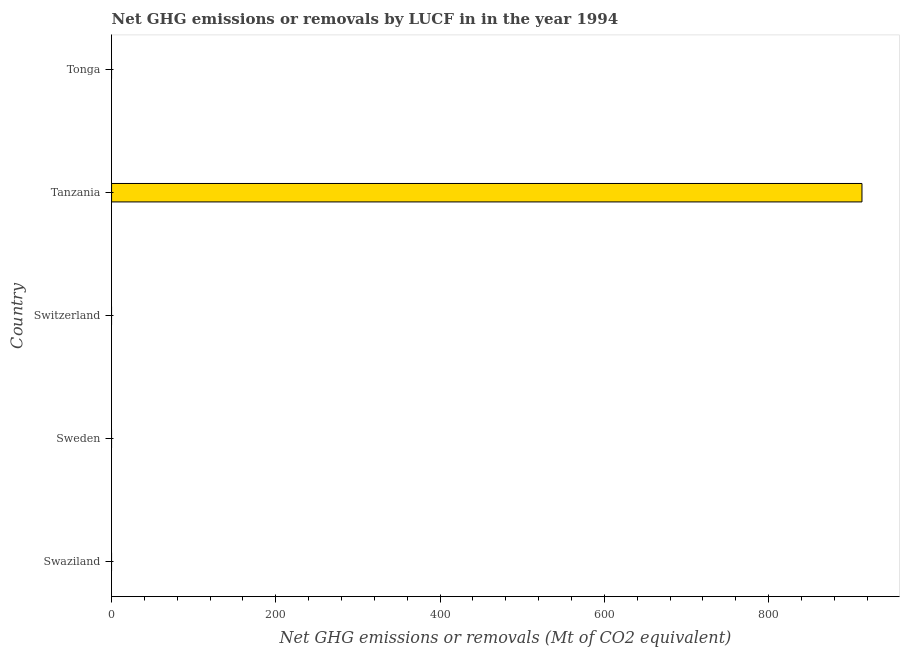Does the graph contain any zero values?
Keep it short and to the point. Yes. Does the graph contain grids?
Your response must be concise. No. What is the title of the graph?
Ensure brevity in your answer.  Net GHG emissions or removals by LUCF in in the year 1994. What is the label or title of the X-axis?
Your response must be concise. Net GHG emissions or removals (Mt of CO2 equivalent). What is the label or title of the Y-axis?
Your answer should be very brief. Country. What is the ghg net emissions or removals in Sweden?
Your answer should be very brief. 0. Across all countries, what is the maximum ghg net emissions or removals?
Ensure brevity in your answer.  913.56. In which country was the ghg net emissions or removals maximum?
Make the answer very short. Tanzania. What is the sum of the ghg net emissions or removals?
Offer a terse response. 913.56. What is the average ghg net emissions or removals per country?
Your answer should be compact. 182.71. What is the median ghg net emissions or removals?
Your answer should be compact. 0. In how many countries, is the ghg net emissions or removals greater than 720 Mt?
Provide a succinct answer. 1. What is the difference between the highest and the lowest ghg net emissions or removals?
Offer a very short reply. 913.56. In how many countries, is the ghg net emissions or removals greater than the average ghg net emissions or removals taken over all countries?
Ensure brevity in your answer.  1. How many bars are there?
Offer a very short reply. 1. What is the Net GHG emissions or removals (Mt of CO2 equivalent) in Swaziland?
Provide a short and direct response. 0. What is the Net GHG emissions or removals (Mt of CO2 equivalent) in Sweden?
Offer a terse response. 0. What is the Net GHG emissions or removals (Mt of CO2 equivalent) of Tanzania?
Your answer should be compact. 913.56. 